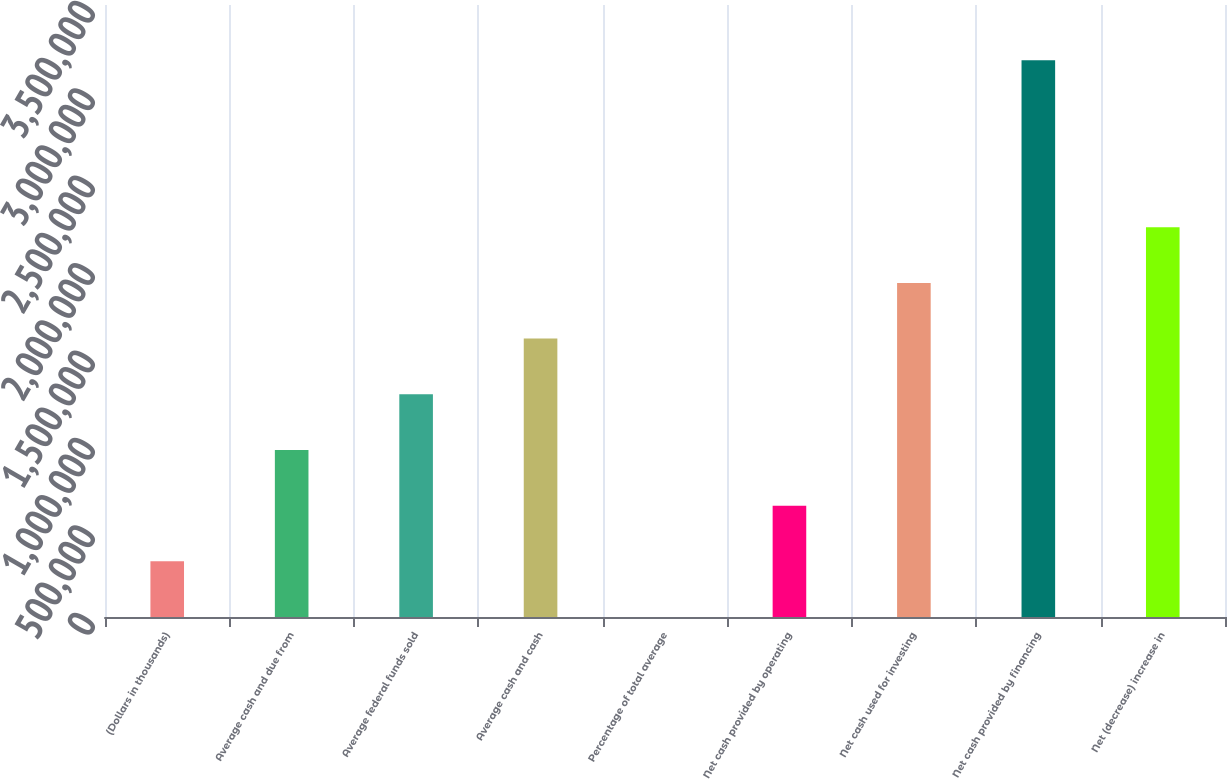Convert chart. <chart><loc_0><loc_0><loc_500><loc_500><bar_chart><fcel>(Dollars in thousands)<fcel>Average cash and due from<fcel>Average federal funds sold<fcel>Average cash and cash<fcel>Percentage of total average<fcel>Net cash provided by operating<fcel>Net cash used for investing<fcel>Net cash provided by financing<fcel>Net (decrease) increase in<nl><fcel>318411<fcel>955213<fcel>1.27361e+06<fcel>1.59201e+06<fcel>10.6<fcel>636812<fcel>1.91042e+06<fcel>3.18402e+06<fcel>2.22882e+06<nl></chart> 